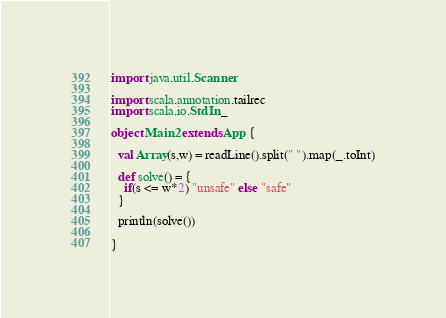<code> <loc_0><loc_0><loc_500><loc_500><_Scala_>import java.util.Scanner

import scala.annotation.tailrec
import scala.io.StdIn._

object Main2 extends App {

  val Array(s,w) = readLine().split(" ").map(_.toInt)

  def solve() = {
    if(s <= w*2) "unsafe" else "safe"
  }

  println(solve())

}

</code> 